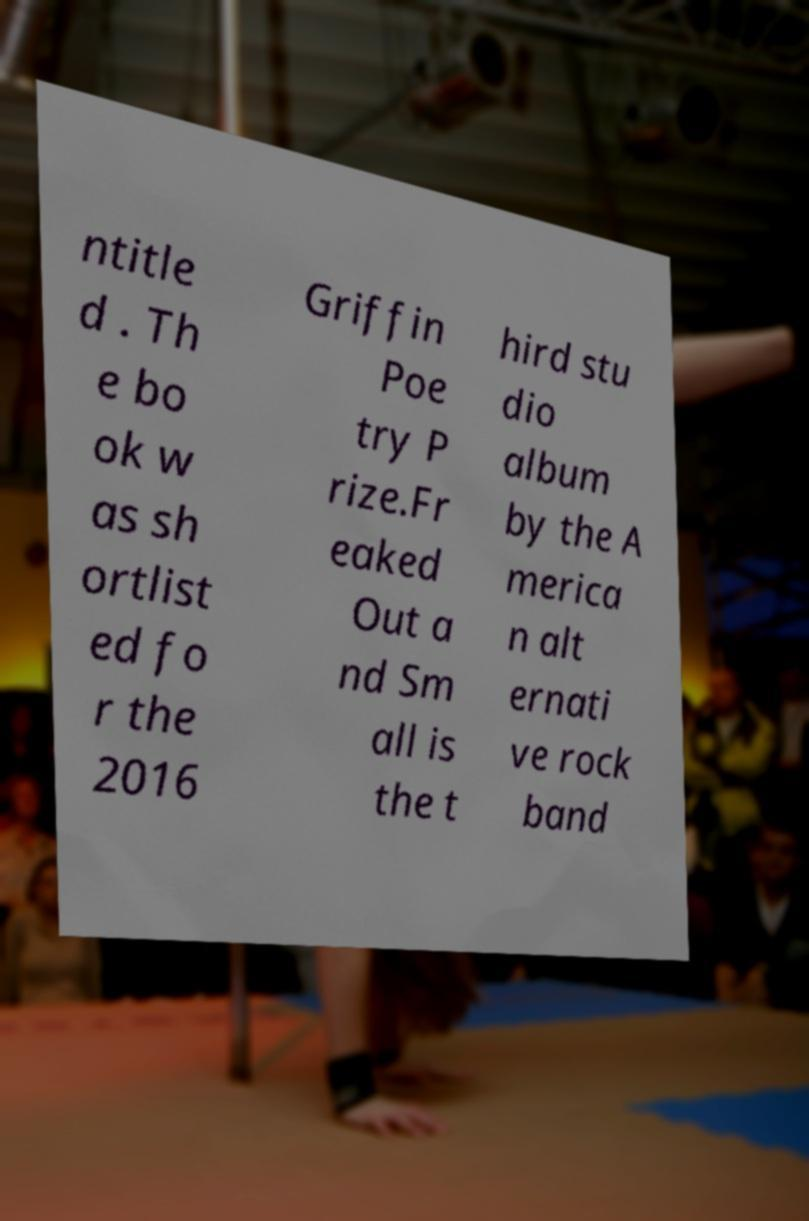Could you extract and type out the text from this image? ntitle d . Th e bo ok w as sh ortlist ed fo r the 2016 Griffin Poe try P rize.Fr eaked Out a nd Sm all is the t hird stu dio album by the A merica n alt ernati ve rock band 